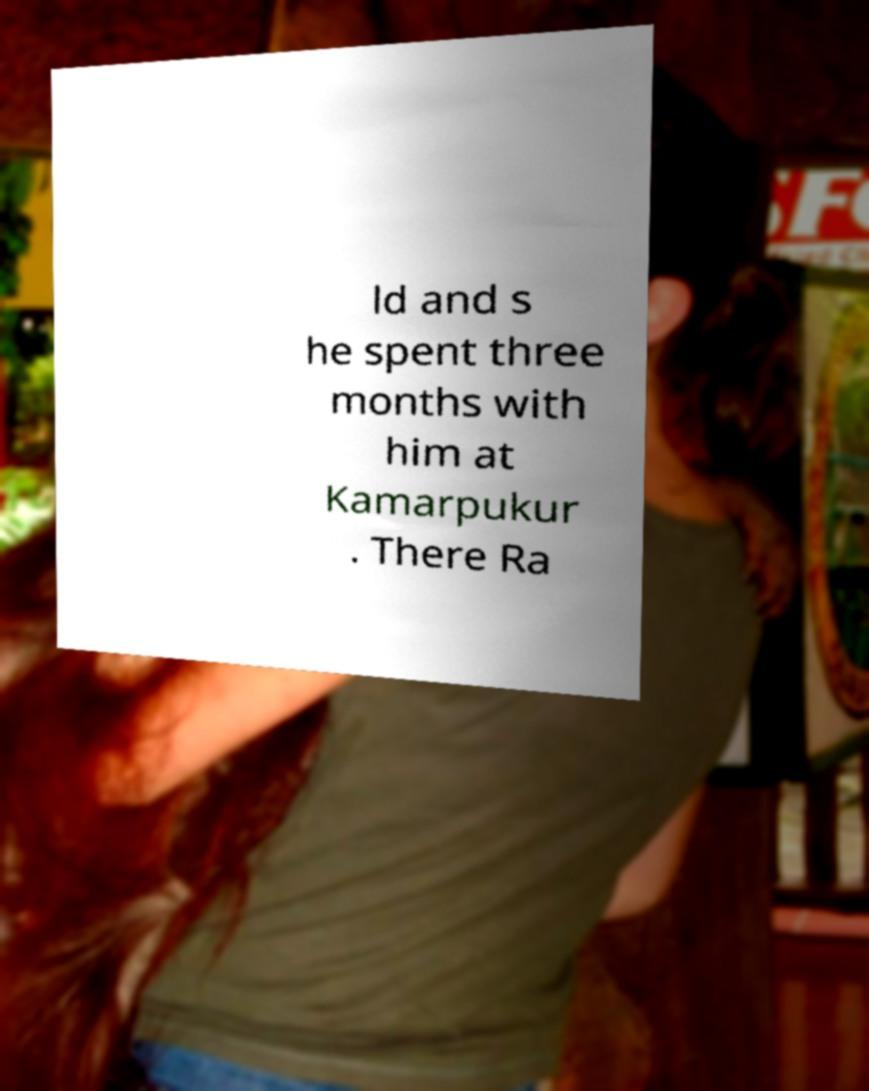Could you assist in decoding the text presented in this image and type it out clearly? ld and s he spent three months with him at Kamarpukur . There Ra 